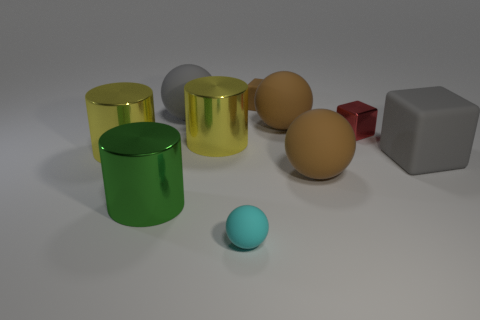Subtract all yellow shiny cylinders. How many cylinders are left? 1 Subtract 2 spheres. How many spheres are left? 2 Subtract all blue spheres. How many yellow cylinders are left? 2 Subtract all cylinders. How many objects are left? 7 Subtract all green cylinders. How many cylinders are left? 2 Subtract all small brown shiny cylinders. Subtract all yellow metal objects. How many objects are left? 8 Add 7 red metallic blocks. How many red metallic blocks are left? 8 Add 3 red shiny objects. How many red shiny objects exist? 4 Subtract 1 cyan spheres. How many objects are left? 9 Subtract all blue cylinders. Subtract all gray blocks. How many cylinders are left? 3 